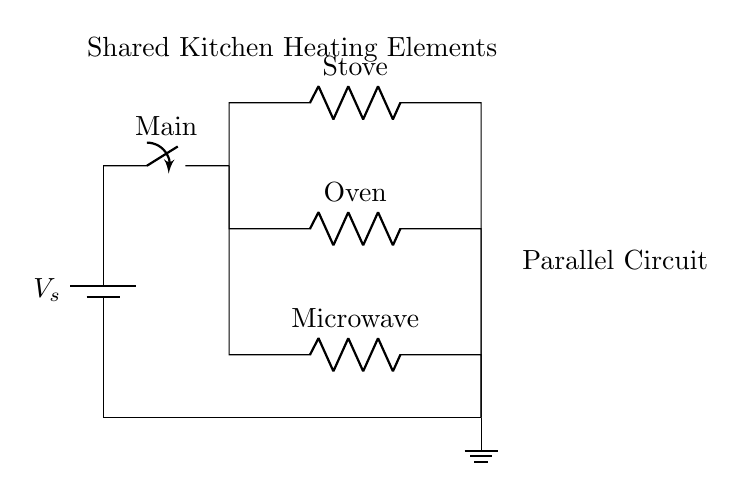What are the components in this circuit? The components include a battery, a main switch, and three heating elements: a stove, an oven, and a microwave. Each element is represented by a resistor in the diagram.
Answer: battery, main switch, stove, oven, microwave What is the type of connection for the heating elements? The heating elements are connected in a parallel configuration, which means they all share the same voltage and can operate independently of one another.
Answer: parallel What is the total voltage supplied by the power source? The voltage supplied by the power source is not directly indicated on the circuit, but it is typically denoted as V_s. In practical applications, this could be standard voltages like 120V or 240V depending on the country.
Answer: V_s How many branches are there in this circuit? The circuit has three branches each corresponding to one heating element: stove, oven, and microwave. These branches indicate separate paths for the current.
Answer: three If one heating element fails, what happens to the others? In a parallel circuit, if one heating element fails (like a resistor breaking), it doesn't affect the operation of the others, as they operate independently. The current can still flow through the remaining branches.
Answer: they continue to function What is the purpose of the main switch in the circuit? The main switch is used to control the overall flow of power in the circuit. By opening or closing this switch, the user can turn all heating elements on or off at once.
Answer: control power What is the role of the ground in this circuit? The ground in the circuit provides a reference point for the voltage in the circuit and ensures safety by preventing potential overloads, directing excess current away from the components.
Answer: safety reference 